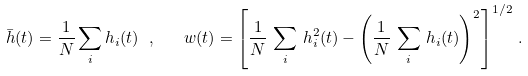Convert formula to latex. <formula><loc_0><loc_0><loc_500><loc_500>\bar { h } ( t ) = \frac { 1 } { N } \sum _ { i } h _ { i } ( t ) \ , \quad w ( t ) = \left [ \frac { 1 } { N } \, \sum _ { i } \, h ^ { 2 } _ { i } ( t ) - \left ( \frac { 1 } { N } \, \sum _ { i } \, h _ { i } ( t ) \right ) ^ { 2 } \right ] ^ { 1 / 2 } \, .</formula> 